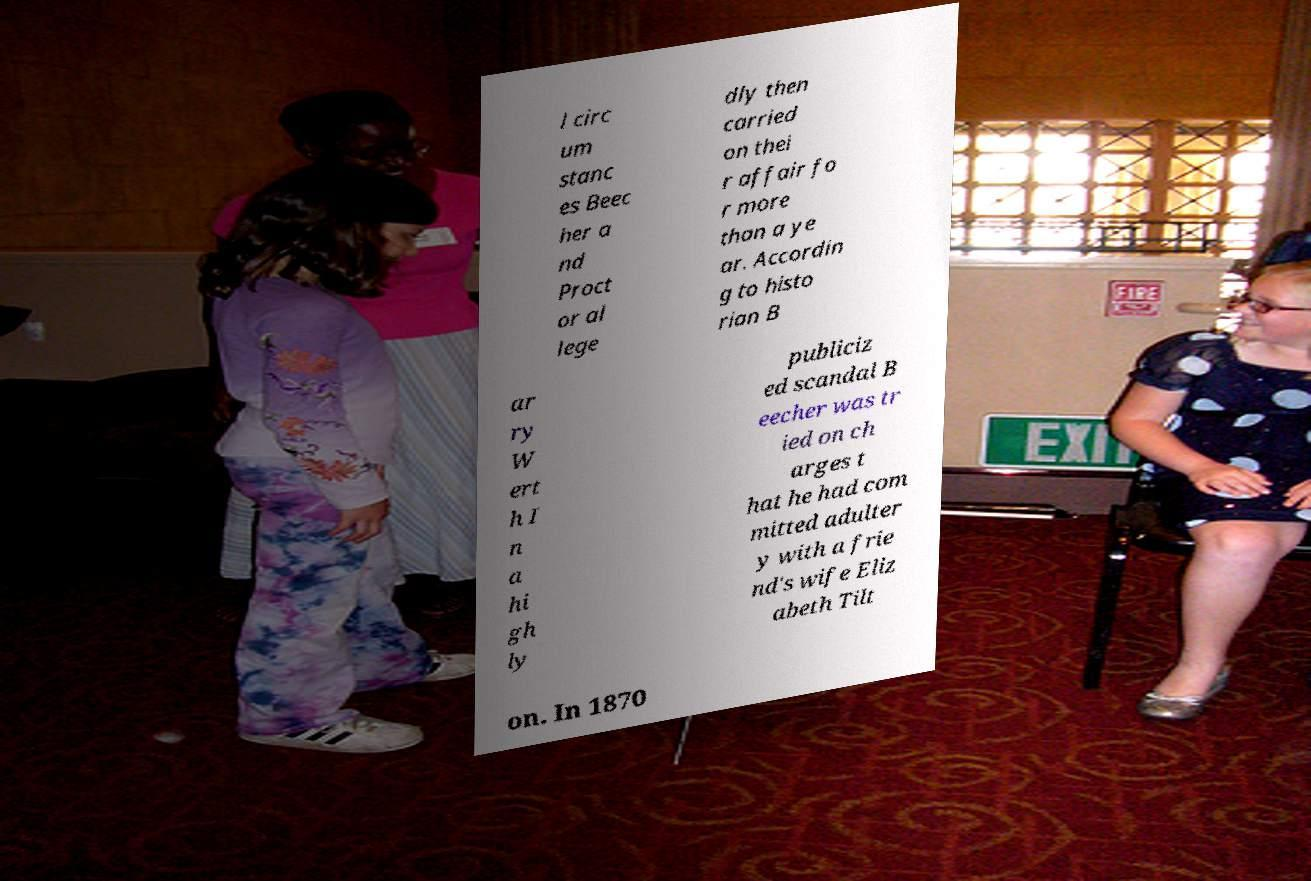Could you assist in decoding the text presented in this image and type it out clearly? l circ um stanc es Beec her a nd Proct or al lege dly then carried on thei r affair fo r more than a ye ar. Accordin g to histo rian B ar ry W ert h I n a hi gh ly publiciz ed scandal B eecher was tr ied on ch arges t hat he had com mitted adulter y with a frie nd's wife Eliz abeth Tilt on. In 1870 